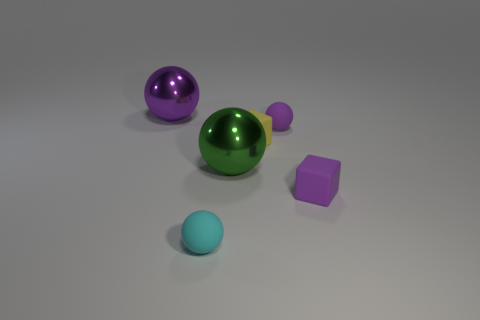Add 3 small rubber cubes. How many objects exist? 9 Subtract all spheres. How many objects are left? 2 Add 4 big purple balls. How many big purple balls are left? 5 Add 1 large green shiny things. How many large green shiny things exist? 2 Subtract 0 blue cubes. How many objects are left? 6 Subtract all tiny yellow cylinders. Subtract all yellow cubes. How many objects are left? 5 